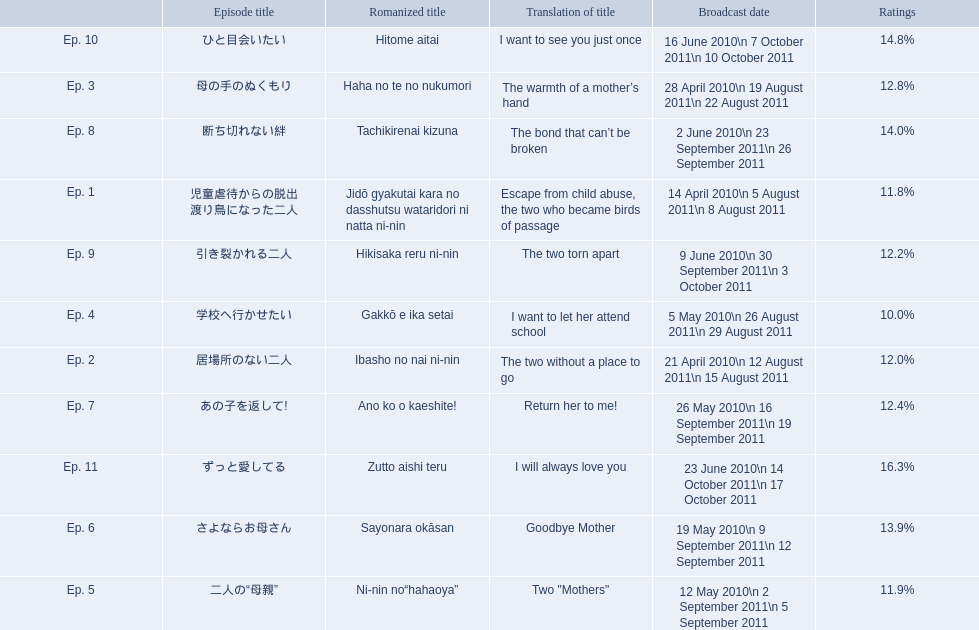How many total episodes are there? Ep. 1, Ep. 2, Ep. 3, Ep. 4, Ep. 5, Ep. 6, Ep. 7, Ep. 8, Ep. 9, Ep. 10, Ep. 11. Of those episodes, which one has the title of the bond that can't be broken? Ep. 8. What was the ratings percentage for that episode? 14.0%. 